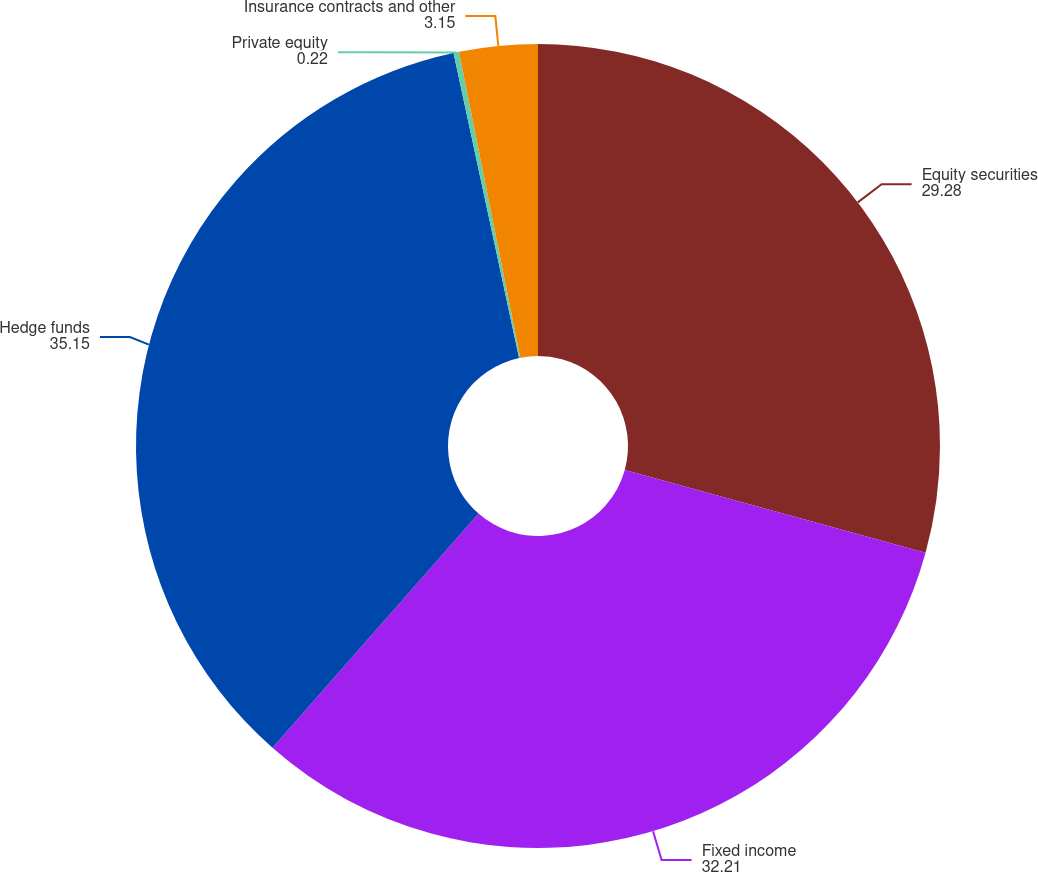Convert chart to OTSL. <chart><loc_0><loc_0><loc_500><loc_500><pie_chart><fcel>Equity securities<fcel>Fixed income<fcel>Hedge funds<fcel>Private equity<fcel>Insurance contracts and other<nl><fcel>29.28%<fcel>32.21%<fcel>35.15%<fcel>0.22%<fcel>3.15%<nl></chart> 